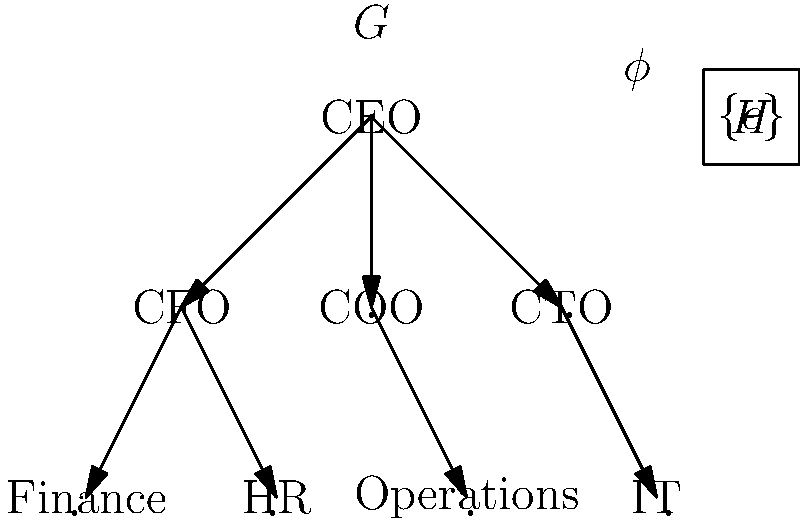In the organizational structure shown above, consider a group homomorphism $\phi: G \rightarrow H$ where $G$ represents the entire organizational hierarchy and $H = \{e\}$ is the trivial group. If $\ker(\phi)$ represents the set of all employees who report directly or indirectly to the COO, how many elements are in $\ker(\phi)$, and what does this tell us about the nature of $\phi$? Let's approach this step-by-step:

1) First, recall that for a group homomorphism $\phi: G \rightarrow H$, the kernel $\ker(\phi)$ is the set of all elements in $G$ that map to the identity element in $H$.

2) In this case, $H = \{e\}$ is the trivial group, so every element in $G$ must map to $e$ in $H$.

3) This means that $\ker(\phi) = G$, i.e., the kernel includes all elements of $G$.

4) Now, we need to count the elements that report directly or indirectly to the COO:
   - COO
   - Operations department

5) This gives us 2 elements in $\ker(\phi)$.

6) However, we know that $\ker(\phi) = G$, which means it should include all 8 positions in the organization.

7) This discrepancy tells us that the given condition about $\ker(\phi)$ representing only those reporting to the COO is incorrect.

8) In fact, $\phi$ is the trivial homomorphism that maps every element of $G$ to the identity element of $H$.

9) This type of homomorphism is called the trivial homomorphism and it always exists between any two groups.

10) The fact that $\ker(\phi) = G$ tells us that $\phi$ is not injective (one-to-one), as multiple elements of $G$ map to the same element in $H$.
Answer: 8 elements; $\phi$ is the trivial homomorphism 